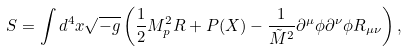<formula> <loc_0><loc_0><loc_500><loc_500>S = \int d ^ { 4 } x \sqrt { - g } \left ( \frac { 1 } { 2 } M _ { p } ^ { 2 } R + P ( X ) - \frac { 1 } { { \tilde { M } } ^ { 2 } } \partial ^ { \mu } \phi \partial ^ { \nu } \phi R _ { \mu \nu } \right ) ,</formula> 